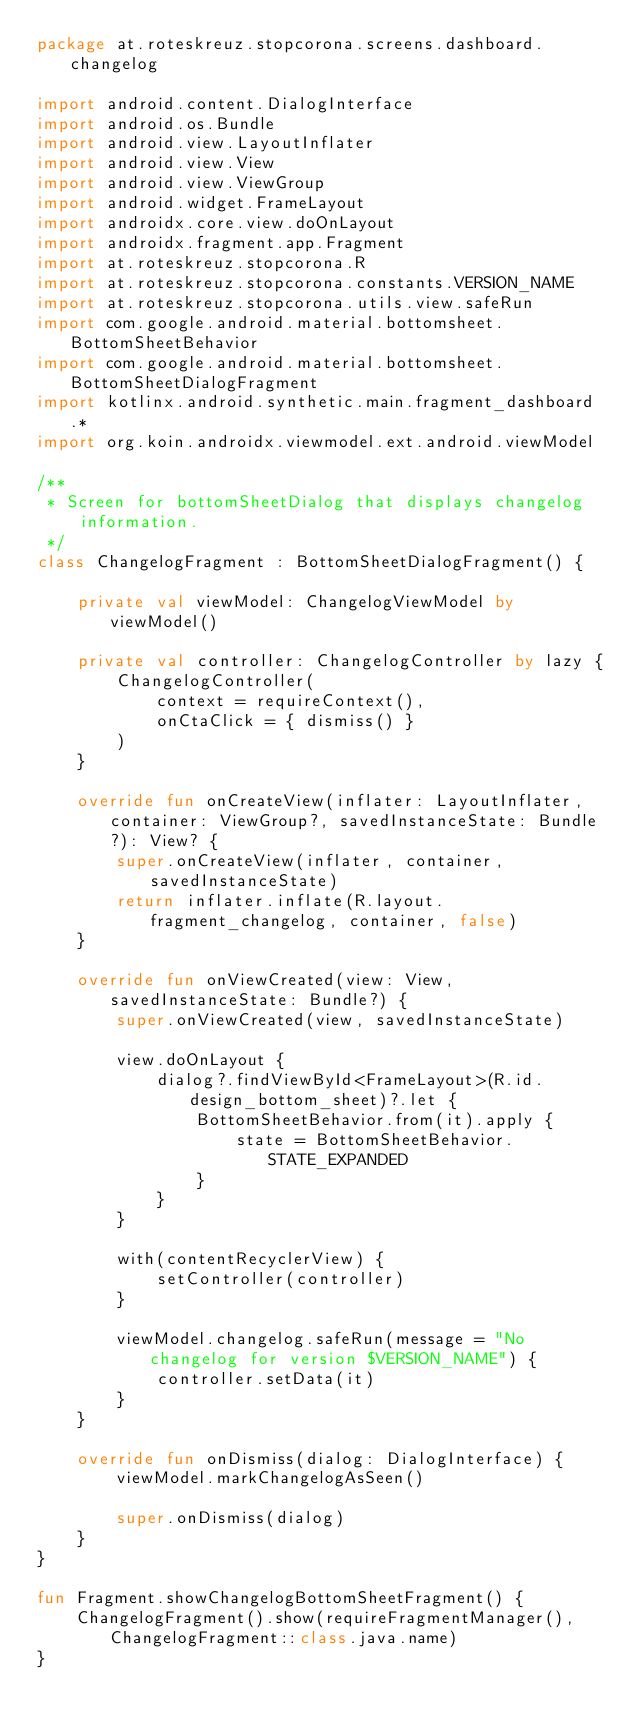Convert code to text. <code><loc_0><loc_0><loc_500><loc_500><_Kotlin_>package at.roteskreuz.stopcorona.screens.dashboard.changelog

import android.content.DialogInterface
import android.os.Bundle
import android.view.LayoutInflater
import android.view.View
import android.view.ViewGroup
import android.widget.FrameLayout
import androidx.core.view.doOnLayout
import androidx.fragment.app.Fragment
import at.roteskreuz.stopcorona.R
import at.roteskreuz.stopcorona.constants.VERSION_NAME
import at.roteskreuz.stopcorona.utils.view.safeRun
import com.google.android.material.bottomsheet.BottomSheetBehavior
import com.google.android.material.bottomsheet.BottomSheetDialogFragment
import kotlinx.android.synthetic.main.fragment_dashboard.*
import org.koin.androidx.viewmodel.ext.android.viewModel

/**
 * Screen for bottomSheetDialog that displays changelog information.
 */
class ChangelogFragment : BottomSheetDialogFragment() {

    private val viewModel: ChangelogViewModel by viewModel()

    private val controller: ChangelogController by lazy {
        ChangelogController(
            context = requireContext(),
            onCtaClick = { dismiss() }
        )
    }

    override fun onCreateView(inflater: LayoutInflater, container: ViewGroup?, savedInstanceState: Bundle?): View? {
        super.onCreateView(inflater, container, savedInstanceState)
        return inflater.inflate(R.layout.fragment_changelog, container, false)
    }

    override fun onViewCreated(view: View, savedInstanceState: Bundle?) {
        super.onViewCreated(view, savedInstanceState)

        view.doOnLayout {
            dialog?.findViewById<FrameLayout>(R.id.design_bottom_sheet)?.let {
                BottomSheetBehavior.from(it).apply {
                    state = BottomSheetBehavior.STATE_EXPANDED
                }
            }
        }

        with(contentRecyclerView) {
            setController(controller)
        }

        viewModel.changelog.safeRun(message = "No changelog for version $VERSION_NAME") {
            controller.setData(it)
        }
    }

    override fun onDismiss(dialog: DialogInterface) {
        viewModel.markChangelogAsSeen()

        super.onDismiss(dialog)
    }
}

fun Fragment.showChangelogBottomSheetFragment() {
    ChangelogFragment().show(requireFragmentManager(), ChangelogFragment::class.java.name)
}
</code> 